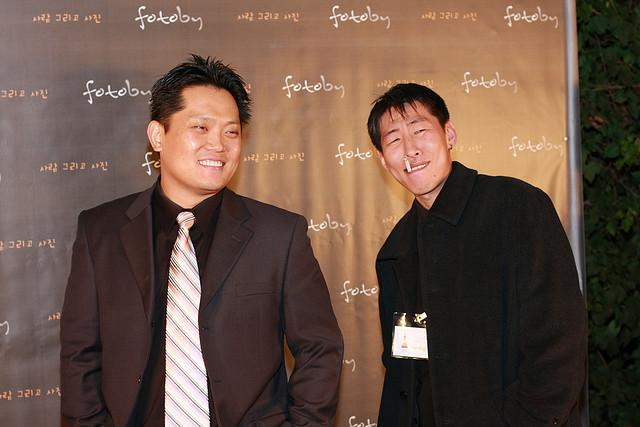Where do these people stand? Please explain your reasoning. photo backdrop. By the setting and the posing they are doing, it is easy to tell where and what they are doing. 